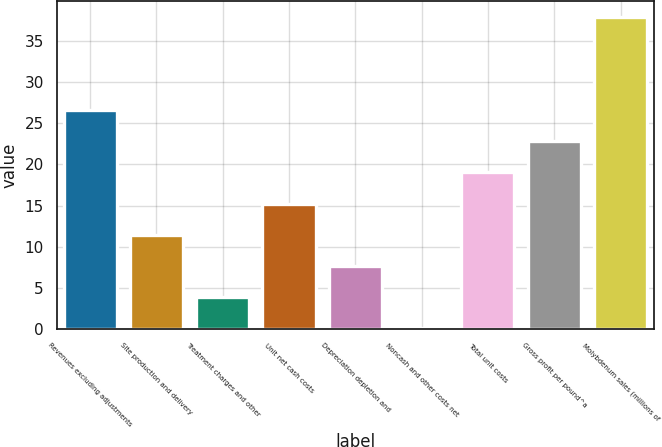<chart> <loc_0><loc_0><loc_500><loc_500><bar_chart><fcel>Revenues excluding adjustments<fcel>Site production and delivery<fcel>Treatment charges and other<fcel>Unit net cash costs<fcel>Depreciation depletion and<fcel>Noncash and other costs net<fcel>Total unit costs<fcel>Gross profit per pound^a<fcel>Molybdenum sales (millions of<nl><fcel>26.64<fcel>11.44<fcel>3.84<fcel>15.24<fcel>7.64<fcel>0.04<fcel>19.04<fcel>22.84<fcel>38<nl></chart> 